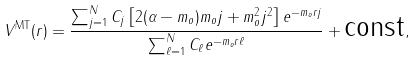<formula> <loc_0><loc_0><loc_500><loc_500>V ^ { \text {MT} } ( r ) = \frac { \sum _ { j = 1 } ^ { N } C _ { j } \left [ 2 ( \alpha - m _ { o } ) m _ { o } j + m _ { o } ^ { 2 } j ^ { 2 } \right ] e ^ { - m _ { o } r j } } { \sum _ { \ell = 1 } ^ { N } C _ { \ell } e ^ { - m _ { o } r \ell } } + \text {const} ,</formula> 